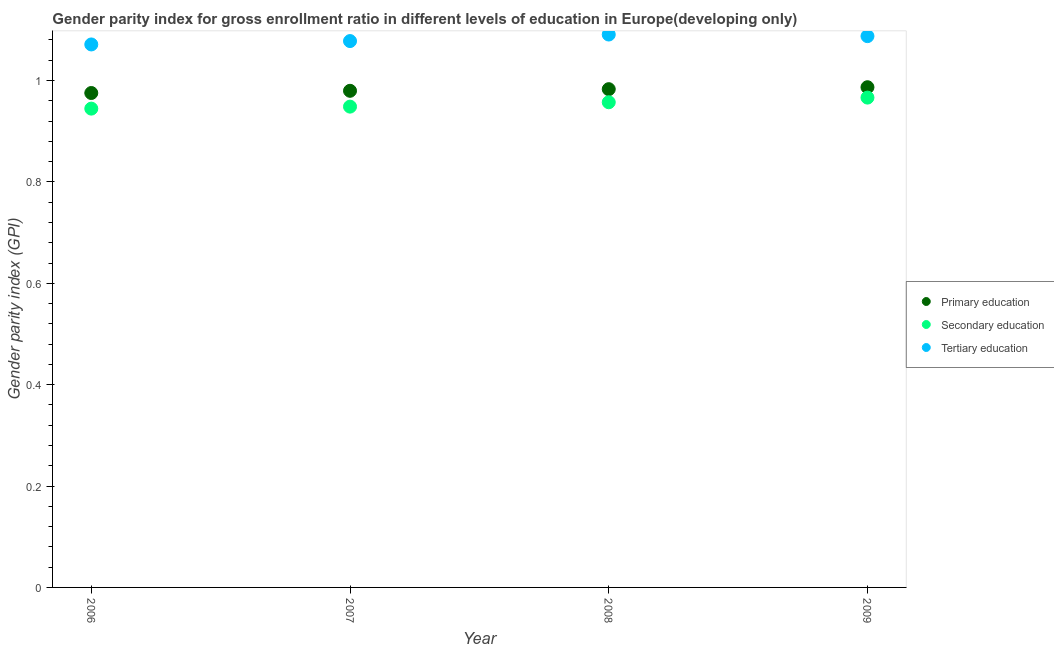What is the gender parity index in primary education in 2009?
Offer a very short reply. 0.99. Across all years, what is the maximum gender parity index in tertiary education?
Keep it short and to the point. 1.09. Across all years, what is the minimum gender parity index in tertiary education?
Ensure brevity in your answer.  1.07. In which year was the gender parity index in tertiary education minimum?
Give a very brief answer. 2006. What is the total gender parity index in secondary education in the graph?
Offer a very short reply. 3.82. What is the difference between the gender parity index in tertiary education in 2006 and that in 2007?
Give a very brief answer. -0.01. What is the difference between the gender parity index in secondary education in 2006 and the gender parity index in tertiary education in 2008?
Your response must be concise. -0.15. What is the average gender parity index in primary education per year?
Give a very brief answer. 0.98. In the year 2007, what is the difference between the gender parity index in tertiary education and gender parity index in secondary education?
Provide a succinct answer. 0.13. In how many years, is the gender parity index in primary education greater than 0.48000000000000004?
Ensure brevity in your answer.  4. What is the ratio of the gender parity index in tertiary education in 2008 to that in 2009?
Provide a succinct answer. 1. Is the gender parity index in primary education in 2008 less than that in 2009?
Offer a terse response. Yes. Is the difference between the gender parity index in secondary education in 2006 and 2007 greater than the difference between the gender parity index in tertiary education in 2006 and 2007?
Keep it short and to the point. Yes. What is the difference between the highest and the second highest gender parity index in tertiary education?
Ensure brevity in your answer.  0. What is the difference between the highest and the lowest gender parity index in secondary education?
Your answer should be compact. 0.02. Is the sum of the gender parity index in primary education in 2008 and 2009 greater than the maximum gender parity index in secondary education across all years?
Give a very brief answer. Yes. Is the gender parity index in tertiary education strictly greater than the gender parity index in secondary education over the years?
Provide a succinct answer. Yes. Is the gender parity index in tertiary education strictly less than the gender parity index in primary education over the years?
Provide a short and direct response. No. How many years are there in the graph?
Provide a short and direct response. 4. What is the difference between two consecutive major ticks on the Y-axis?
Offer a terse response. 0.2. Where does the legend appear in the graph?
Your response must be concise. Center right. What is the title of the graph?
Keep it short and to the point. Gender parity index for gross enrollment ratio in different levels of education in Europe(developing only). Does "Ages 15-64" appear as one of the legend labels in the graph?
Your response must be concise. No. What is the label or title of the Y-axis?
Your answer should be very brief. Gender parity index (GPI). What is the Gender parity index (GPI) in Primary education in 2006?
Provide a succinct answer. 0.98. What is the Gender parity index (GPI) of Secondary education in 2006?
Your answer should be very brief. 0.94. What is the Gender parity index (GPI) in Tertiary education in 2006?
Offer a very short reply. 1.07. What is the Gender parity index (GPI) of Primary education in 2007?
Offer a terse response. 0.98. What is the Gender parity index (GPI) in Secondary education in 2007?
Your answer should be very brief. 0.95. What is the Gender parity index (GPI) in Tertiary education in 2007?
Provide a short and direct response. 1.08. What is the Gender parity index (GPI) of Primary education in 2008?
Provide a short and direct response. 0.98. What is the Gender parity index (GPI) of Secondary education in 2008?
Ensure brevity in your answer.  0.96. What is the Gender parity index (GPI) in Tertiary education in 2008?
Provide a succinct answer. 1.09. What is the Gender parity index (GPI) of Primary education in 2009?
Make the answer very short. 0.99. What is the Gender parity index (GPI) of Secondary education in 2009?
Keep it short and to the point. 0.97. What is the Gender parity index (GPI) in Tertiary education in 2009?
Provide a short and direct response. 1.09. Across all years, what is the maximum Gender parity index (GPI) of Primary education?
Ensure brevity in your answer.  0.99. Across all years, what is the maximum Gender parity index (GPI) of Secondary education?
Keep it short and to the point. 0.97. Across all years, what is the maximum Gender parity index (GPI) of Tertiary education?
Ensure brevity in your answer.  1.09. Across all years, what is the minimum Gender parity index (GPI) of Primary education?
Your response must be concise. 0.98. Across all years, what is the minimum Gender parity index (GPI) of Secondary education?
Your answer should be very brief. 0.94. Across all years, what is the minimum Gender parity index (GPI) of Tertiary education?
Offer a very short reply. 1.07. What is the total Gender parity index (GPI) of Primary education in the graph?
Offer a very short reply. 3.92. What is the total Gender parity index (GPI) in Secondary education in the graph?
Give a very brief answer. 3.82. What is the total Gender parity index (GPI) in Tertiary education in the graph?
Give a very brief answer. 4.33. What is the difference between the Gender parity index (GPI) of Primary education in 2006 and that in 2007?
Give a very brief answer. -0. What is the difference between the Gender parity index (GPI) of Secondary education in 2006 and that in 2007?
Provide a short and direct response. -0. What is the difference between the Gender parity index (GPI) of Tertiary education in 2006 and that in 2007?
Keep it short and to the point. -0.01. What is the difference between the Gender parity index (GPI) in Primary education in 2006 and that in 2008?
Make the answer very short. -0.01. What is the difference between the Gender parity index (GPI) in Secondary education in 2006 and that in 2008?
Provide a succinct answer. -0.01. What is the difference between the Gender parity index (GPI) of Tertiary education in 2006 and that in 2008?
Provide a succinct answer. -0.02. What is the difference between the Gender parity index (GPI) of Primary education in 2006 and that in 2009?
Keep it short and to the point. -0.01. What is the difference between the Gender parity index (GPI) in Secondary education in 2006 and that in 2009?
Your answer should be compact. -0.02. What is the difference between the Gender parity index (GPI) in Tertiary education in 2006 and that in 2009?
Provide a succinct answer. -0.02. What is the difference between the Gender parity index (GPI) of Primary education in 2007 and that in 2008?
Provide a short and direct response. -0. What is the difference between the Gender parity index (GPI) in Secondary education in 2007 and that in 2008?
Offer a terse response. -0.01. What is the difference between the Gender parity index (GPI) in Tertiary education in 2007 and that in 2008?
Offer a terse response. -0.01. What is the difference between the Gender parity index (GPI) in Primary education in 2007 and that in 2009?
Offer a terse response. -0.01. What is the difference between the Gender parity index (GPI) in Secondary education in 2007 and that in 2009?
Offer a terse response. -0.02. What is the difference between the Gender parity index (GPI) in Tertiary education in 2007 and that in 2009?
Keep it short and to the point. -0.01. What is the difference between the Gender parity index (GPI) of Primary education in 2008 and that in 2009?
Your answer should be very brief. -0. What is the difference between the Gender parity index (GPI) in Secondary education in 2008 and that in 2009?
Offer a terse response. -0.01. What is the difference between the Gender parity index (GPI) in Tertiary education in 2008 and that in 2009?
Provide a short and direct response. 0. What is the difference between the Gender parity index (GPI) of Primary education in 2006 and the Gender parity index (GPI) of Secondary education in 2007?
Provide a succinct answer. 0.03. What is the difference between the Gender parity index (GPI) in Primary education in 2006 and the Gender parity index (GPI) in Tertiary education in 2007?
Your answer should be very brief. -0.1. What is the difference between the Gender parity index (GPI) of Secondary education in 2006 and the Gender parity index (GPI) of Tertiary education in 2007?
Make the answer very short. -0.13. What is the difference between the Gender parity index (GPI) in Primary education in 2006 and the Gender parity index (GPI) in Secondary education in 2008?
Offer a very short reply. 0.02. What is the difference between the Gender parity index (GPI) in Primary education in 2006 and the Gender parity index (GPI) in Tertiary education in 2008?
Offer a terse response. -0.12. What is the difference between the Gender parity index (GPI) of Secondary education in 2006 and the Gender parity index (GPI) of Tertiary education in 2008?
Ensure brevity in your answer.  -0.15. What is the difference between the Gender parity index (GPI) of Primary education in 2006 and the Gender parity index (GPI) of Secondary education in 2009?
Your response must be concise. 0.01. What is the difference between the Gender parity index (GPI) in Primary education in 2006 and the Gender parity index (GPI) in Tertiary education in 2009?
Make the answer very short. -0.11. What is the difference between the Gender parity index (GPI) in Secondary education in 2006 and the Gender parity index (GPI) in Tertiary education in 2009?
Offer a terse response. -0.14. What is the difference between the Gender parity index (GPI) in Primary education in 2007 and the Gender parity index (GPI) in Secondary education in 2008?
Give a very brief answer. 0.02. What is the difference between the Gender parity index (GPI) of Primary education in 2007 and the Gender parity index (GPI) of Tertiary education in 2008?
Keep it short and to the point. -0.11. What is the difference between the Gender parity index (GPI) of Secondary education in 2007 and the Gender parity index (GPI) of Tertiary education in 2008?
Make the answer very short. -0.14. What is the difference between the Gender parity index (GPI) of Primary education in 2007 and the Gender parity index (GPI) of Secondary education in 2009?
Offer a terse response. 0.01. What is the difference between the Gender parity index (GPI) in Primary education in 2007 and the Gender parity index (GPI) in Tertiary education in 2009?
Provide a succinct answer. -0.11. What is the difference between the Gender parity index (GPI) in Secondary education in 2007 and the Gender parity index (GPI) in Tertiary education in 2009?
Give a very brief answer. -0.14. What is the difference between the Gender parity index (GPI) in Primary education in 2008 and the Gender parity index (GPI) in Secondary education in 2009?
Keep it short and to the point. 0.02. What is the difference between the Gender parity index (GPI) of Primary education in 2008 and the Gender parity index (GPI) of Tertiary education in 2009?
Provide a succinct answer. -0.1. What is the difference between the Gender parity index (GPI) in Secondary education in 2008 and the Gender parity index (GPI) in Tertiary education in 2009?
Your answer should be compact. -0.13. What is the average Gender parity index (GPI) of Primary education per year?
Provide a succinct answer. 0.98. What is the average Gender parity index (GPI) in Secondary education per year?
Provide a short and direct response. 0.95. What is the average Gender parity index (GPI) of Tertiary education per year?
Ensure brevity in your answer.  1.08. In the year 2006, what is the difference between the Gender parity index (GPI) in Primary education and Gender parity index (GPI) in Secondary education?
Offer a very short reply. 0.03. In the year 2006, what is the difference between the Gender parity index (GPI) in Primary education and Gender parity index (GPI) in Tertiary education?
Ensure brevity in your answer.  -0.1. In the year 2006, what is the difference between the Gender parity index (GPI) in Secondary education and Gender parity index (GPI) in Tertiary education?
Give a very brief answer. -0.13. In the year 2007, what is the difference between the Gender parity index (GPI) in Primary education and Gender parity index (GPI) in Secondary education?
Ensure brevity in your answer.  0.03. In the year 2007, what is the difference between the Gender parity index (GPI) in Primary education and Gender parity index (GPI) in Tertiary education?
Provide a short and direct response. -0.1. In the year 2007, what is the difference between the Gender parity index (GPI) of Secondary education and Gender parity index (GPI) of Tertiary education?
Offer a terse response. -0.13. In the year 2008, what is the difference between the Gender parity index (GPI) in Primary education and Gender parity index (GPI) in Secondary education?
Offer a very short reply. 0.03. In the year 2008, what is the difference between the Gender parity index (GPI) of Primary education and Gender parity index (GPI) of Tertiary education?
Ensure brevity in your answer.  -0.11. In the year 2008, what is the difference between the Gender parity index (GPI) in Secondary education and Gender parity index (GPI) in Tertiary education?
Your response must be concise. -0.13. In the year 2009, what is the difference between the Gender parity index (GPI) in Primary education and Gender parity index (GPI) in Secondary education?
Keep it short and to the point. 0.02. In the year 2009, what is the difference between the Gender parity index (GPI) in Primary education and Gender parity index (GPI) in Tertiary education?
Ensure brevity in your answer.  -0.1. In the year 2009, what is the difference between the Gender parity index (GPI) of Secondary education and Gender parity index (GPI) of Tertiary education?
Provide a succinct answer. -0.12. What is the ratio of the Gender parity index (GPI) in Secondary education in 2006 to that in 2007?
Ensure brevity in your answer.  1. What is the ratio of the Gender parity index (GPI) of Tertiary education in 2006 to that in 2007?
Offer a terse response. 0.99. What is the ratio of the Gender parity index (GPI) of Secondary education in 2006 to that in 2008?
Keep it short and to the point. 0.99. What is the ratio of the Gender parity index (GPI) of Tertiary education in 2006 to that in 2008?
Give a very brief answer. 0.98. What is the ratio of the Gender parity index (GPI) in Primary education in 2006 to that in 2009?
Offer a terse response. 0.99. What is the ratio of the Gender parity index (GPI) in Secondary education in 2006 to that in 2009?
Offer a very short reply. 0.98. What is the ratio of the Gender parity index (GPI) of Tertiary education in 2006 to that in 2009?
Your answer should be compact. 0.98. What is the ratio of the Gender parity index (GPI) in Primary education in 2007 to that in 2008?
Make the answer very short. 1. What is the ratio of the Gender parity index (GPI) in Secondary education in 2007 to that in 2008?
Give a very brief answer. 0.99. What is the ratio of the Gender parity index (GPI) in Tertiary education in 2007 to that in 2008?
Keep it short and to the point. 0.99. What is the ratio of the Gender parity index (GPI) in Primary education in 2007 to that in 2009?
Your response must be concise. 0.99. What is the ratio of the Gender parity index (GPI) of Secondary education in 2007 to that in 2009?
Provide a succinct answer. 0.98. What is the ratio of the Gender parity index (GPI) in Tertiary education in 2007 to that in 2009?
Your answer should be compact. 0.99. What is the ratio of the Gender parity index (GPI) in Primary education in 2008 to that in 2009?
Your response must be concise. 1. What is the ratio of the Gender parity index (GPI) of Secondary education in 2008 to that in 2009?
Your answer should be compact. 0.99. What is the ratio of the Gender parity index (GPI) in Tertiary education in 2008 to that in 2009?
Your answer should be compact. 1. What is the difference between the highest and the second highest Gender parity index (GPI) in Primary education?
Offer a terse response. 0. What is the difference between the highest and the second highest Gender parity index (GPI) in Secondary education?
Make the answer very short. 0.01. What is the difference between the highest and the second highest Gender parity index (GPI) in Tertiary education?
Offer a very short reply. 0. What is the difference between the highest and the lowest Gender parity index (GPI) of Primary education?
Offer a terse response. 0.01. What is the difference between the highest and the lowest Gender parity index (GPI) of Secondary education?
Keep it short and to the point. 0.02. What is the difference between the highest and the lowest Gender parity index (GPI) of Tertiary education?
Your response must be concise. 0.02. 